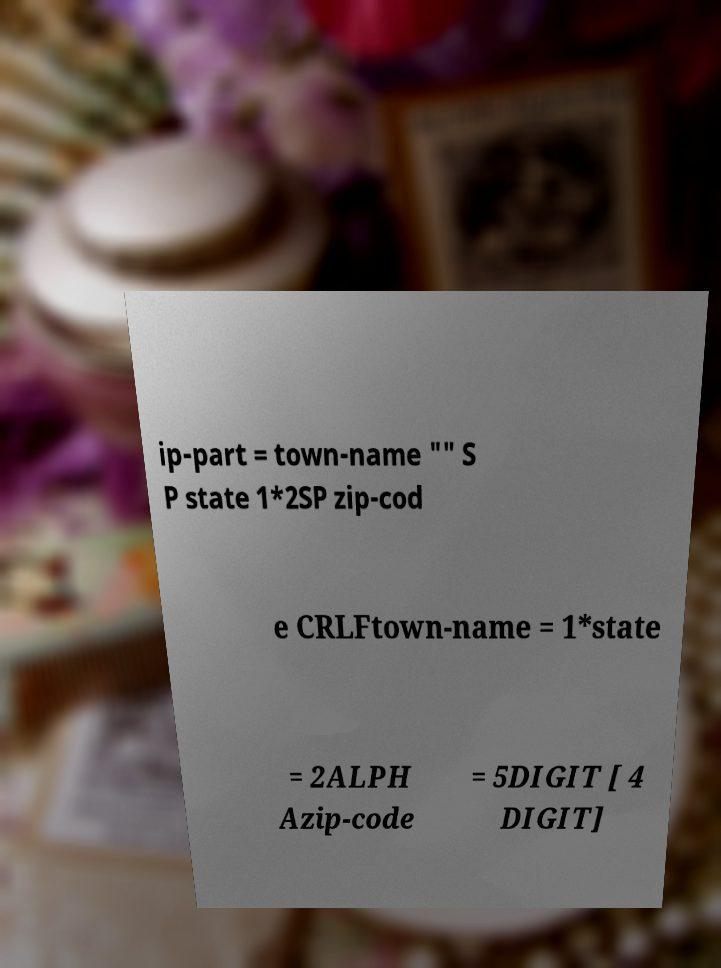Please read and relay the text visible in this image. What does it say? ip-part = town-name "" S P state 1*2SP zip-cod e CRLFtown-name = 1*state = 2ALPH Azip-code = 5DIGIT [ 4 DIGIT] 